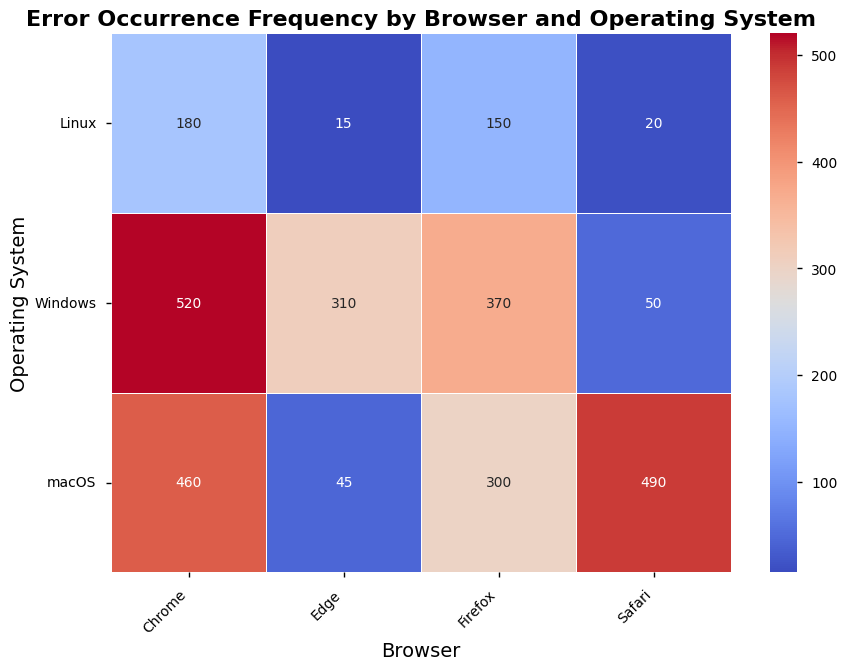Which browser has the highest error count when using Windows? By looking at the heatmap, we see the cell corresponding to Chrome and Windows has the darkest color and the highest number, signifying the highest error count.
Answer: Chrome Which operating system has the least error count when using Firefox? First, identify the cells under the Firefox column. Then, find the lightest-colored cell or the one with the smallest number, which corresponds to Linux.
Answer: Linux What is the total number of errors for Safari across all operating systems? Add the numbers in the Safari column: 50 (Windows) + 490 (macOS) + 20 (Linux). The calculation is 50 + 490 + 20 = 560.
Answer: 560 Compare the error counts between Edge on macOS and Edge on Linux. Which one is higher? Look at the two cells corresponding to Edge on macOS (45) and Edge on Linux (15). The higher value is 45, which is for macOS.
Answer: macOS Are the error counts for Chrome on Windows higher or lower than Firefox on Windows? Compare the values: Chrome on Windows (520) and Firefox on Windows (370). Since 520 is greater than 370, Chrome on Windows has a higher error count.
Answer: Higher What’s the difference in error counts between Chrome on macOS and Edge on Windows? Subtract the error count for Edge on Windows (310) from Chrome on macOS (460). The calculation is 460 - 310 = 150.
Answer: 150 Which browser has the highest error count on macOS? In the macOS row, find the cell with the highest value, which corresponds to Safari with an error count of 490.
Answer: Safari If you sum the error counts for Firefox across all operating systems, what value do you get? Add the numbers in the Firefox column: 370 (Windows) + 300 (macOS) + 150 (Linux). The calculation is 370 + 300 + 150 = 820.
Answer: 820 Which combination of browser and operating system has the lowest error count in the dataset? The lightest-colored cell in the heatmap corresponds to Edge on Linux, which has an error count of 15.
Answer: Edge on Linux Compare the error counts for Safari on Windows and Linux. Which one is higher? Look at the cells corresponding to Safari on Windows (50) and Safari on Linux (20). The higher value is 50, which is for Windows.
Answer: Windows 